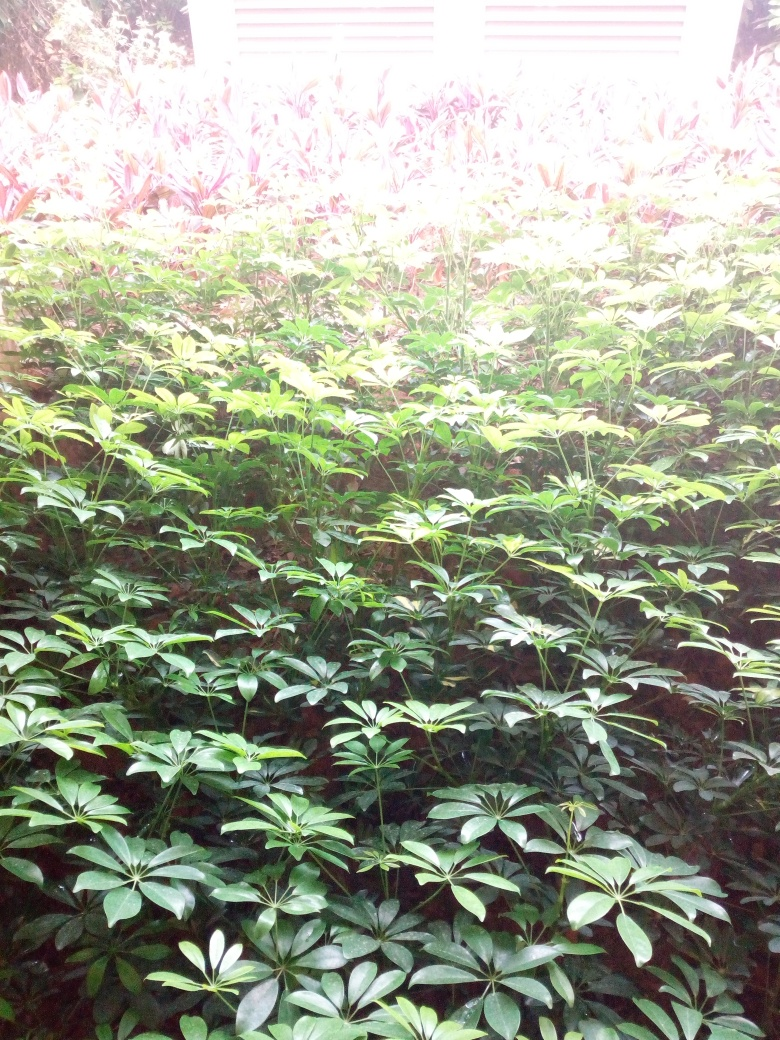Are the colors faded? Although the colors in the image may appear slightly washed out due to overexposure, the foliage retains some vibrancy, especially in the green leaves. The brighter areas suggest a strong light source, possibly sunlight, which might be causing some color fading effect, but overall, the vegetation shows a range of green tones indicating that the colors are not significantly faded. 